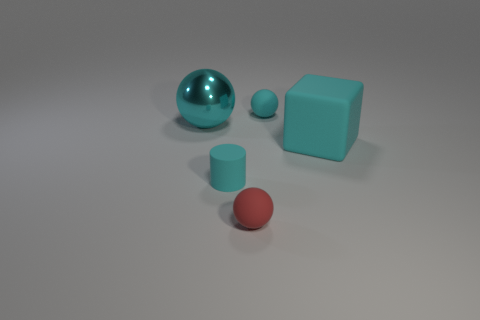Are there any big brown metallic blocks?
Your answer should be very brief. No. Are there an equal number of big cyan cubes that are behind the tiny cyan matte ball and yellow spheres?
Your response must be concise. Yes. What number of other objects are there of the same shape as the small red object?
Your response must be concise. 2. What shape is the large cyan matte thing?
Make the answer very short. Cube. Is the big ball made of the same material as the tiny cyan cylinder?
Offer a terse response. No. Are there an equal number of balls that are in front of the matte cylinder and small cyan rubber things that are right of the large cube?
Your answer should be very brief. No. Is there a large rubber block on the left side of the rubber sphere that is in front of the large cyan object that is to the right of the large metallic ball?
Offer a very short reply. No. Is the red rubber sphere the same size as the shiny thing?
Your answer should be compact. No. There is a rubber sphere that is behind the small cyan rubber object that is on the left side of the cyan object behind the metallic thing; what color is it?
Your answer should be compact. Cyan. How many rubber cylinders are the same color as the shiny ball?
Offer a very short reply. 1. 